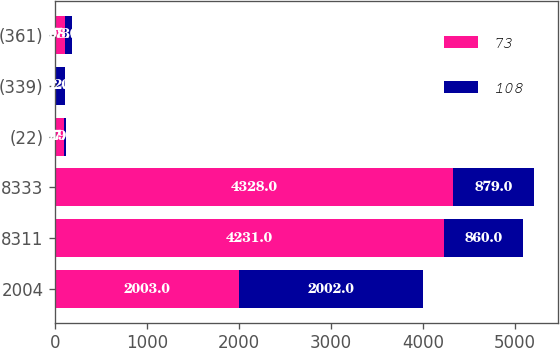Convert chart to OTSL. <chart><loc_0><loc_0><loc_500><loc_500><stacked_bar_chart><ecel><fcel>2004<fcel>8311<fcel>8333<fcel>(22)<fcel>(339)<fcel>(361)<nl><fcel>73<fcel>2003<fcel>4231<fcel>4328<fcel>97<fcel>11<fcel>108<nl><fcel>108<fcel>2002<fcel>860<fcel>879<fcel>19<fcel>92<fcel>73<nl></chart> 